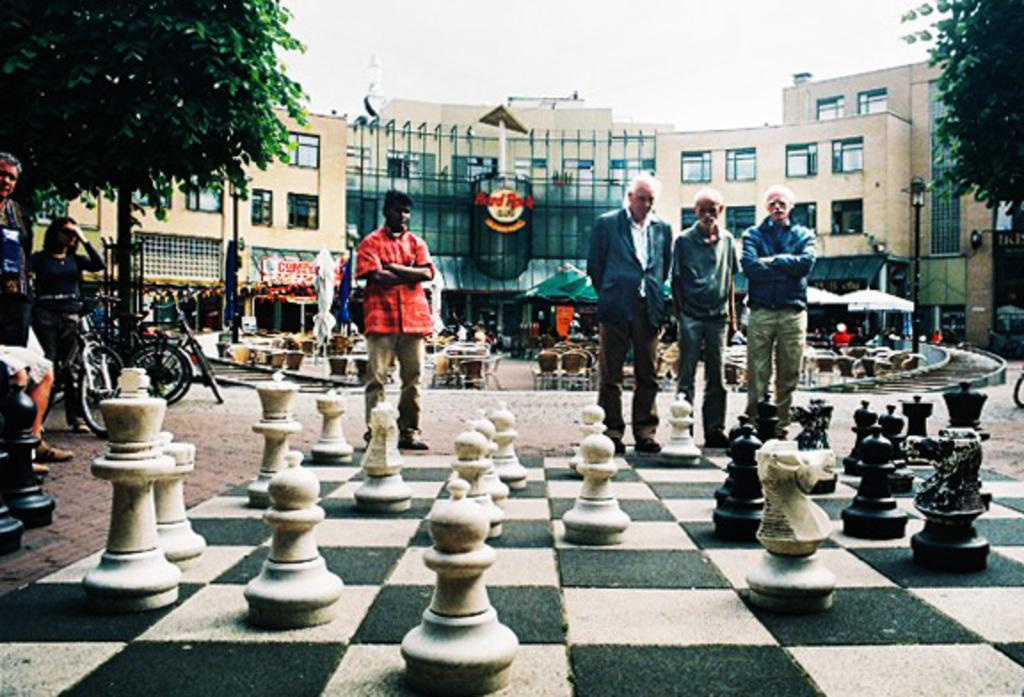<image>
Share a concise interpretation of the image provided. Men are playing a large chess game on a large square in front of a Hard Rock Cafe. 